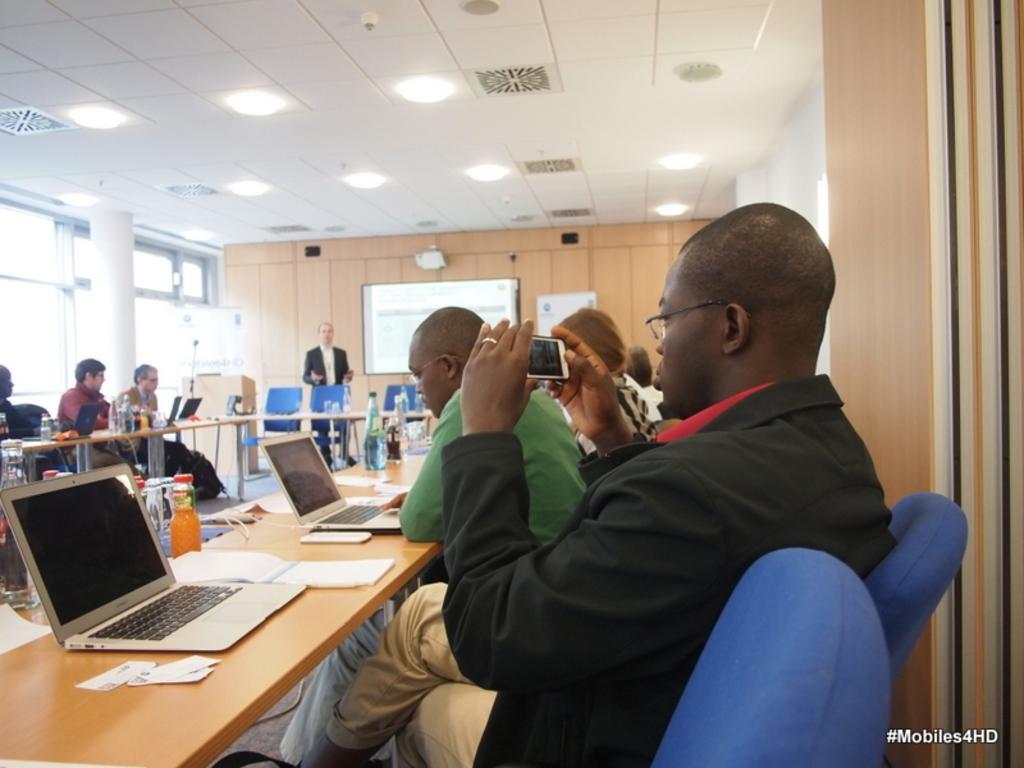Describe this image in one or two sentences. people are seated on the chairs around the table. on the table there are laptops, bottle, papers. a person at the right is holding a phone in his hand. at the back, center a person is standing. behind him there is a projector screen and a wall. on the top there are lights. at the left there is a wall. 